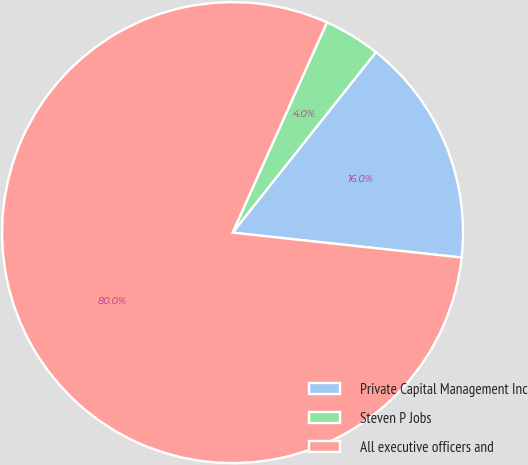Convert chart to OTSL. <chart><loc_0><loc_0><loc_500><loc_500><pie_chart><fcel>Private Capital Management Inc<fcel>Steven P Jobs<fcel>All executive officers and<nl><fcel>16.04%<fcel>3.97%<fcel>79.99%<nl></chart> 